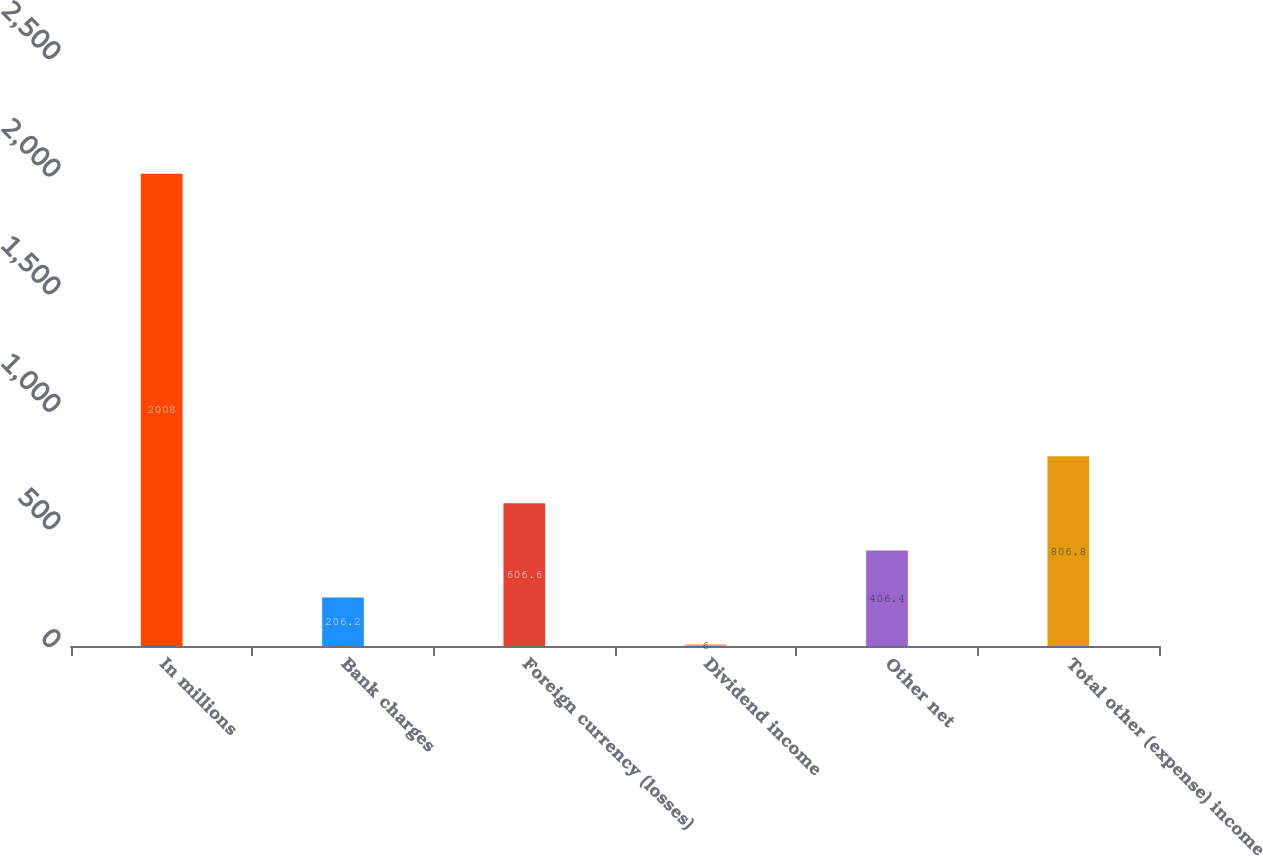Convert chart to OTSL. <chart><loc_0><loc_0><loc_500><loc_500><bar_chart><fcel>In millions<fcel>Bank charges<fcel>Foreign currency (losses)<fcel>Dividend income<fcel>Other net<fcel>Total other (expense) income<nl><fcel>2008<fcel>206.2<fcel>606.6<fcel>6<fcel>406.4<fcel>806.8<nl></chart> 